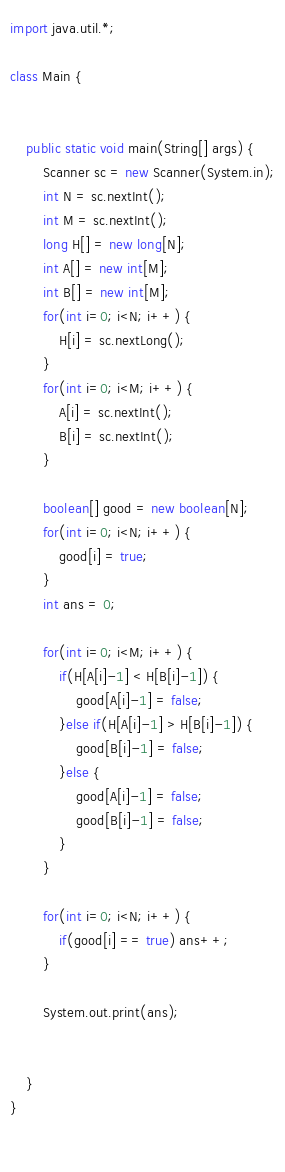<code> <loc_0><loc_0><loc_500><loc_500><_Java_>
import java.util.*;

class Main {
    
	
	public static void main(String[] args) {
        Scanner sc = new Scanner(System.in);
        int N = sc.nextInt();
        int M = sc.nextInt();
        long H[] = new long[N];
        int A[] = new int[M];
        int B[] = new int[M];
        for(int i=0; i<N; i++) {
        	H[i] = sc.nextLong();
        }
        for(int i=0; i<M; i++) {
        	A[i] = sc.nextInt();
        	B[i] = sc.nextInt();        	
        }
        
        boolean[] good = new boolean[N];
        for(int i=0; i<N; i++) {
        	good[i] = true; 
        }
        int ans = 0;
        
        for(int i=0; i<M; i++) {
        	if(H[A[i]-1] < H[B[i]-1]) {
        		good[A[i]-1] = false;
        	}else if(H[A[i]-1] > H[B[i]-1]) {
        		good[B[i]-1] = false;
        	}else {
        		good[A[i]-1] = false;
        		good[B[i]-1] = false;
        	}
        }
        
        for(int i=0; i<N; i++) {
        	if(good[i] == true) ans++; 
        }
        
        System.out.print(ans);
        
       
	}
}
		
	
</code> 